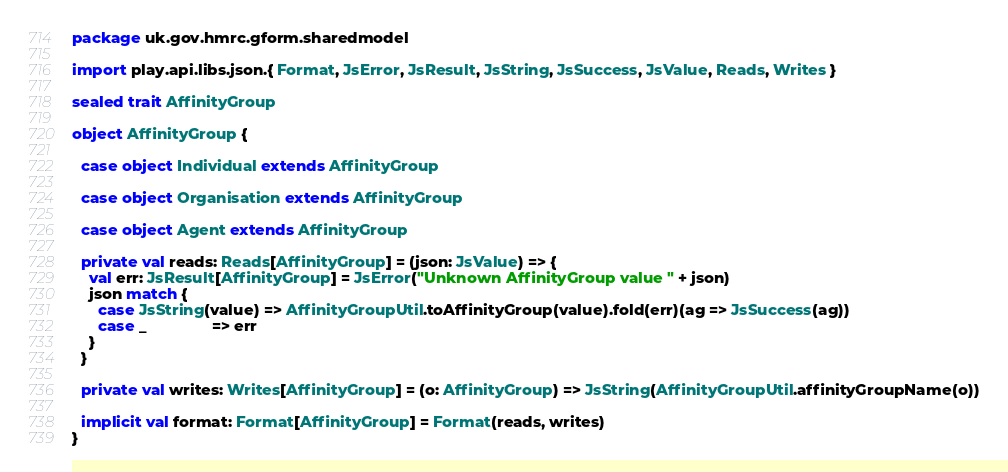Convert code to text. <code><loc_0><loc_0><loc_500><loc_500><_Scala_>
package uk.gov.hmrc.gform.sharedmodel

import play.api.libs.json.{ Format, JsError, JsResult, JsString, JsSuccess, JsValue, Reads, Writes }

sealed trait AffinityGroup

object AffinityGroup {

  case object Individual extends AffinityGroup

  case object Organisation extends AffinityGroup

  case object Agent extends AffinityGroup

  private val reads: Reads[AffinityGroup] = (json: JsValue) => {
    val err: JsResult[AffinityGroup] = JsError("Unknown AffinityGroup value " + json)
    json match {
      case JsString(value) => AffinityGroupUtil.toAffinityGroup(value).fold(err)(ag => JsSuccess(ag))
      case _               => err
    }
  }

  private val writes: Writes[AffinityGroup] = (o: AffinityGroup) => JsString(AffinityGroupUtil.affinityGroupName(o))

  implicit val format: Format[AffinityGroup] = Format(reads, writes)
}
</code> 